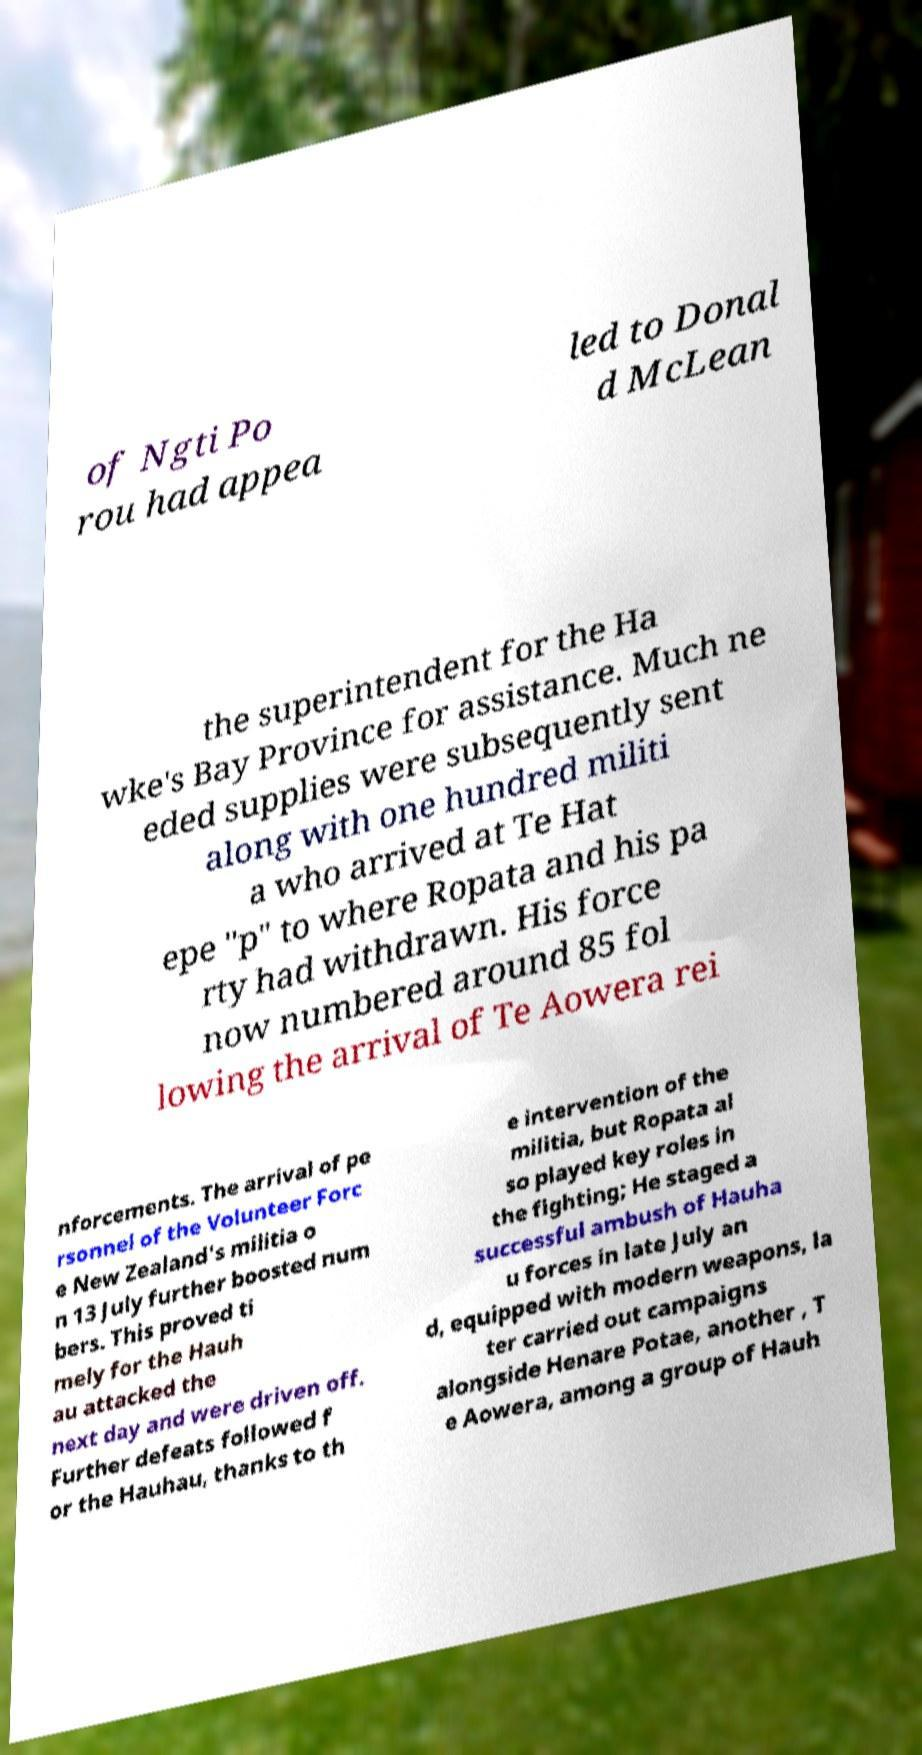What messages or text are displayed in this image? I need them in a readable, typed format. of Ngti Po rou had appea led to Donal d McLean the superintendent for the Ha wke's Bay Province for assistance. Much ne eded supplies were subsequently sent along with one hundred militi a who arrived at Te Hat epe "p" to where Ropata and his pa rty had withdrawn. His force now numbered around 85 fol lowing the arrival of Te Aowera rei nforcements. The arrival of pe rsonnel of the Volunteer Forc e New Zealand's militia o n 13 July further boosted num bers. This proved ti mely for the Hauh au attacked the next day and were driven off. Further defeats followed f or the Hauhau, thanks to th e intervention of the militia, but Ropata al so played key roles in the fighting; He staged a successful ambush of Hauha u forces in late July an d, equipped with modern weapons, la ter carried out campaigns alongside Henare Potae, another , T e Aowera, among a group of Hauh 